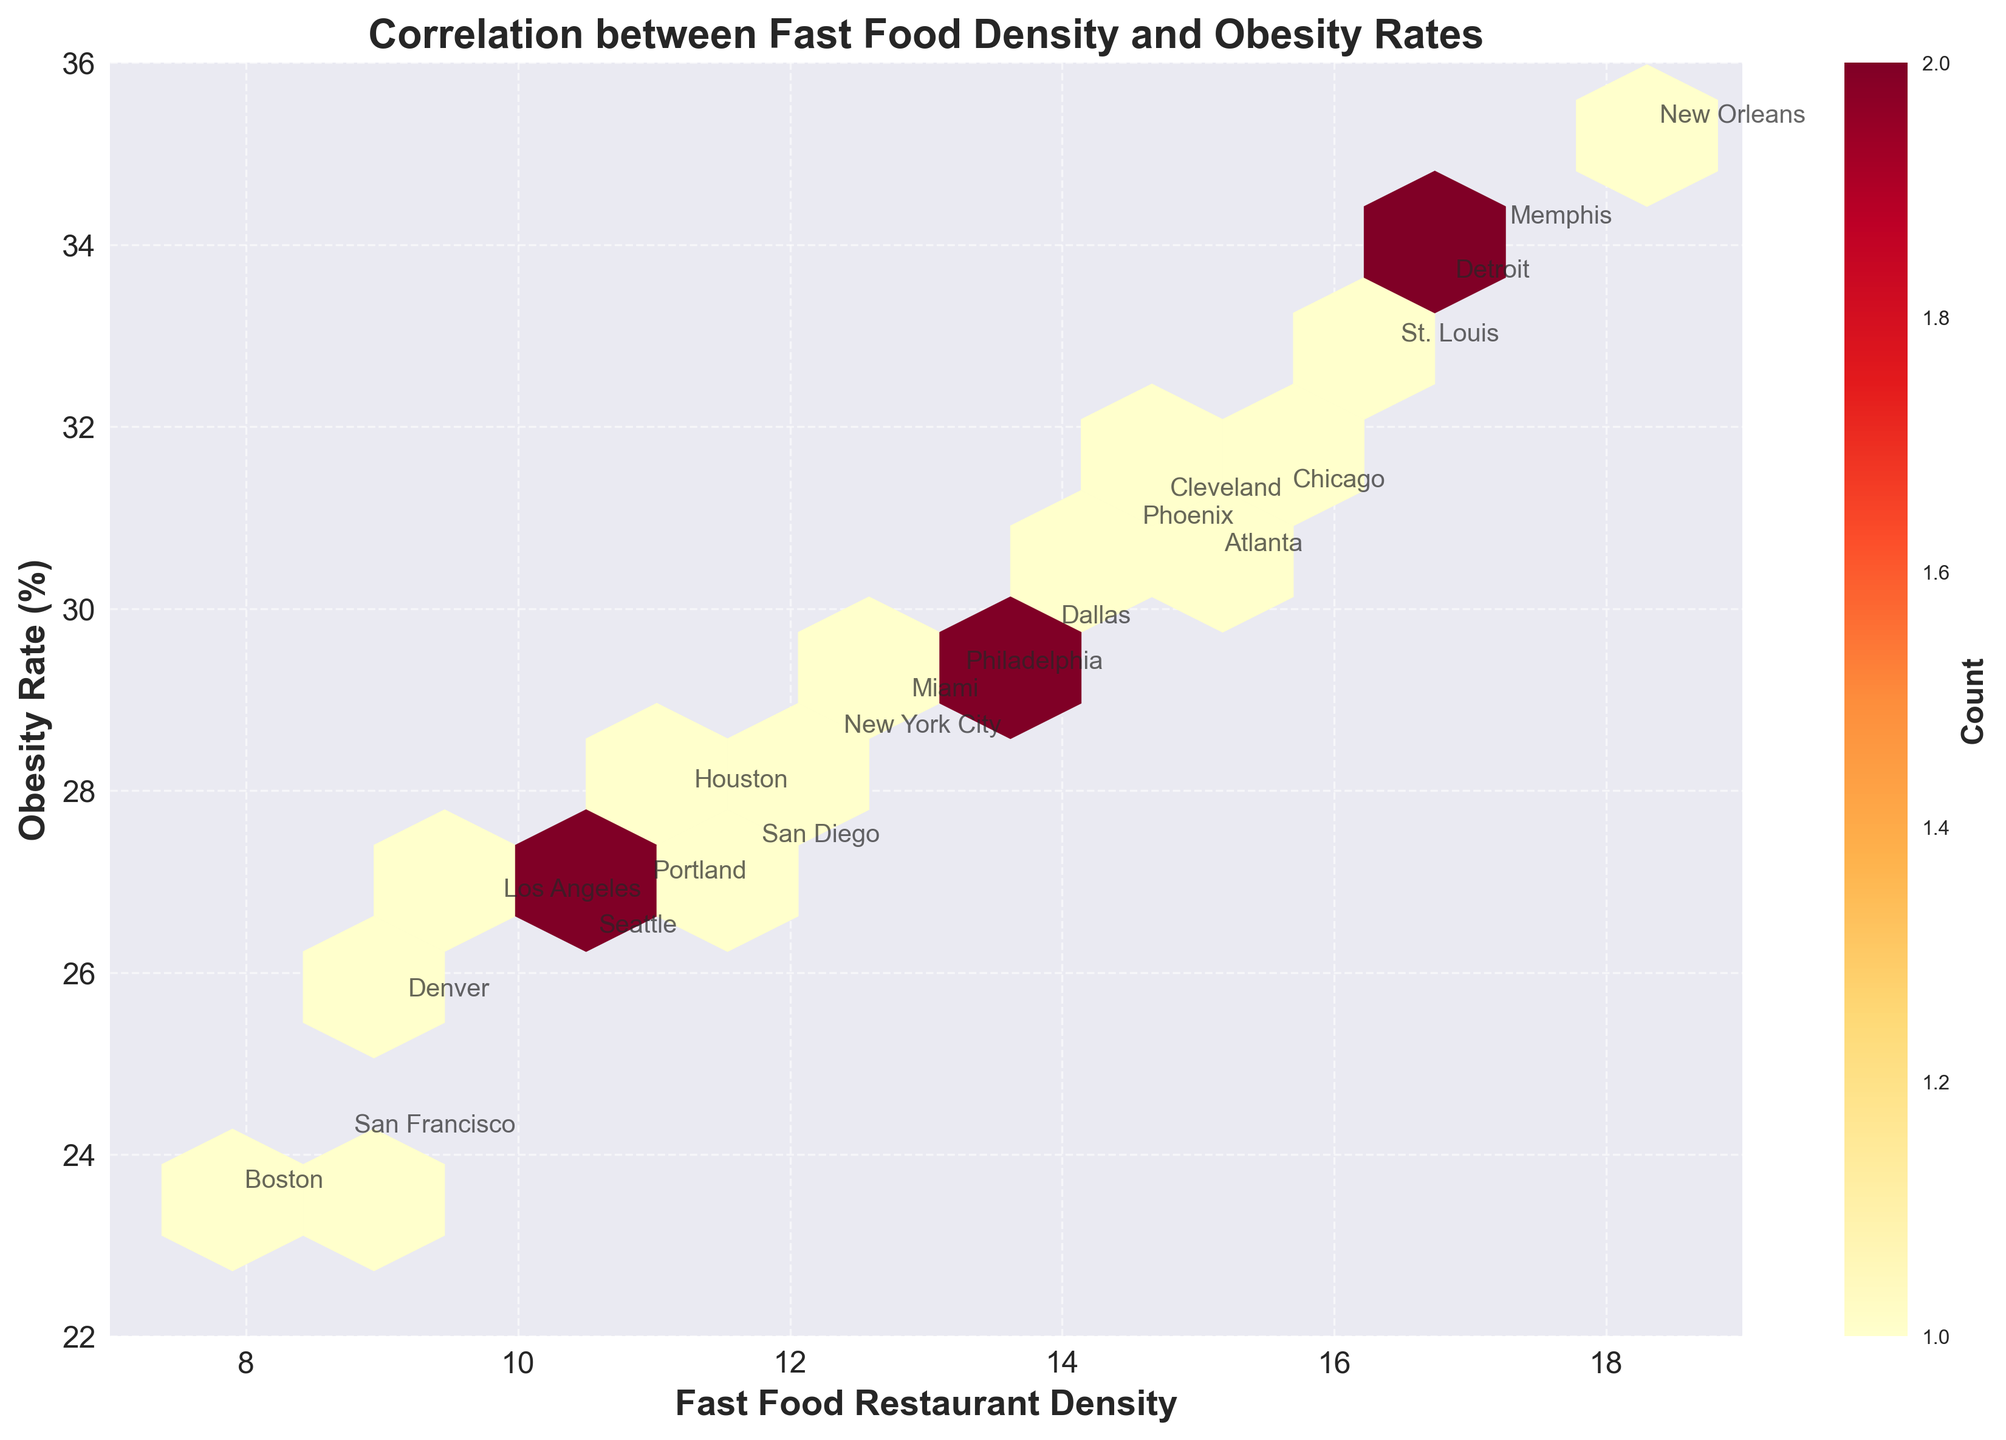What is the title of the figure? The title is located at the top of the figure. It describes the subject of the plot, which in this case is about the relationship between two variables.
Answer: Correlation between Fast Food Density and Obesity Rates What are the variables on the x-axis and y-axis? The labels on the axes provide information about the variables being plotted. The x-axis represents fast food restaurant density, and the y-axis represents obesity rate.
Answer: Fast Food Restaurant Density on x-axis and Obesity Rate (%) on y-axis How many color bins are used in the hexbin plot? By observing the plot, it is possible to count the number of unique colors used. These colors indicate different count densities in the hexbin plot.
Answer: Multiple, exact count not provided Which city has the highest fast food restaurant density? The cities are annotated close to their respective data points on the plot. The highest x-value will indicate the city with the highest fast food density.
Answer: New Orleans What is the range of obesity rates in the plot? Look at the y-axis to find the minimum and maximum values of obesity rates depicted in the plot.
Answer: 22% to 36% How does Boston compare to Memphis in terms of obesity rates? Locate the points and annotations for both cities on the plot. Compare their positions along the y-axis which indicates obesity rates.
Answer: Boston has a lower obesity rate than Memphis Which cities have similar fast food density but different obesity rates? Identify clusters of points with the same x-values but different y-values, and check their annotations.
Answer: San Diego and Portland Is there a general trend visible between fast food density and obesity rates? Observe the overall direction and clustering of the hexagons. If there is a visible upward or downward trend, it indicates a correlation.
Answer: Positive trend Which city stands out as an outlier in terms of high obesity rate? Look for points that lie far outside the general cluster and identify the city annotation.
Answer: New Orleans is an outlier with the highest obesity rate What does the color of the hexagons represent in this plot? Usually, hexbin plots use color to indicate density. Check the color bar legend to understand the meaning of the colors, which typically represent the count of data points within each hexagon.
Answer: Count of data points 